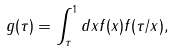Convert formula to latex. <formula><loc_0><loc_0><loc_500><loc_500>g ( \tau ) = \int ^ { 1 } _ { \tau } d x f ( x ) f ( \tau / x ) ,</formula> 